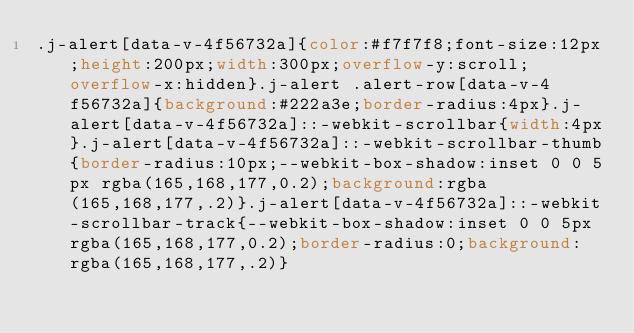<code> <loc_0><loc_0><loc_500><loc_500><_CSS_>.j-alert[data-v-4f56732a]{color:#f7f7f8;font-size:12px;height:200px;width:300px;overflow-y:scroll;overflow-x:hidden}.j-alert .alert-row[data-v-4f56732a]{background:#222a3e;border-radius:4px}.j-alert[data-v-4f56732a]::-webkit-scrollbar{width:4px}.j-alert[data-v-4f56732a]::-webkit-scrollbar-thumb{border-radius:10px;--webkit-box-shadow:inset 0 0 5px rgba(165,168,177,0.2);background:rgba(165,168,177,.2)}.j-alert[data-v-4f56732a]::-webkit-scrollbar-track{--webkit-box-shadow:inset 0 0 5px rgba(165,168,177,0.2);border-radius:0;background:rgba(165,168,177,.2)}</code> 